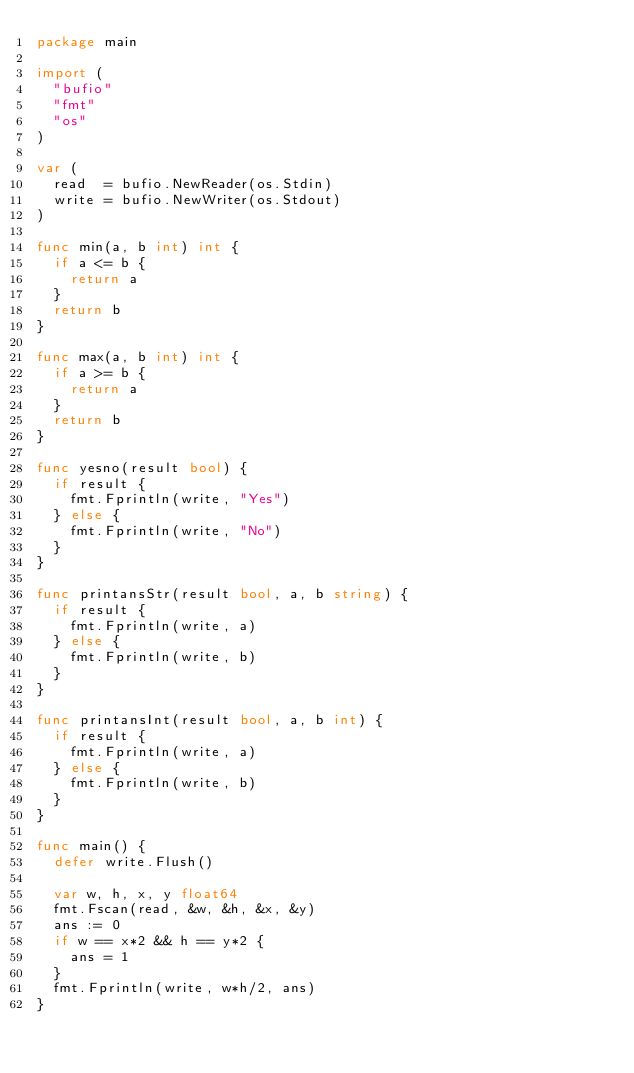Convert code to text. <code><loc_0><loc_0><loc_500><loc_500><_Go_>package main

import (
	"bufio"
	"fmt"
	"os"
)

var (
	read  = bufio.NewReader(os.Stdin)
	write = bufio.NewWriter(os.Stdout)
)

func min(a, b int) int {
	if a <= b {
		return a
	}
	return b
}

func max(a, b int) int {
	if a >= b {
		return a
	}
	return b
}

func yesno(result bool) {
	if result {
		fmt.Fprintln(write, "Yes")
	} else {
		fmt.Fprintln(write, "No")
	}
}

func printansStr(result bool, a, b string) {
	if result {
		fmt.Fprintln(write, a)
	} else {
		fmt.Fprintln(write, b)
	}
}

func printansInt(result bool, a, b int) {
	if result {
		fmt.Fprintln(write, a)
	} else {
		fmt.Fprintln(write, b)
	}
}

func main() {
	defer write.Flush()

	var w, h, x, y float64
	fmt.Fscan(read, &w, &h, &x, &y)
	ans := 0
	if w == x*2 && h == y*2 {
		ans = 1
	}
	fmt.Fprintln(write, w*h/2, ans)
}
</code> 